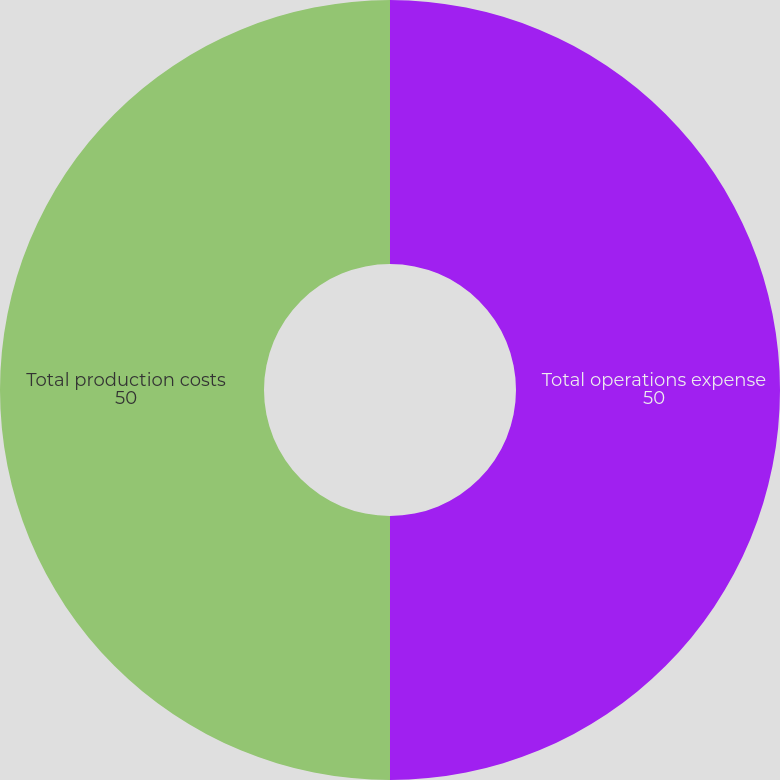<chart> <loc_0><loc_0><loc_500><loc_500><pie_chart><fcel>Total operations expense<fcel>Total production costs<nl><fcel>50.0%<fcel>50.0%<nl></chart> 